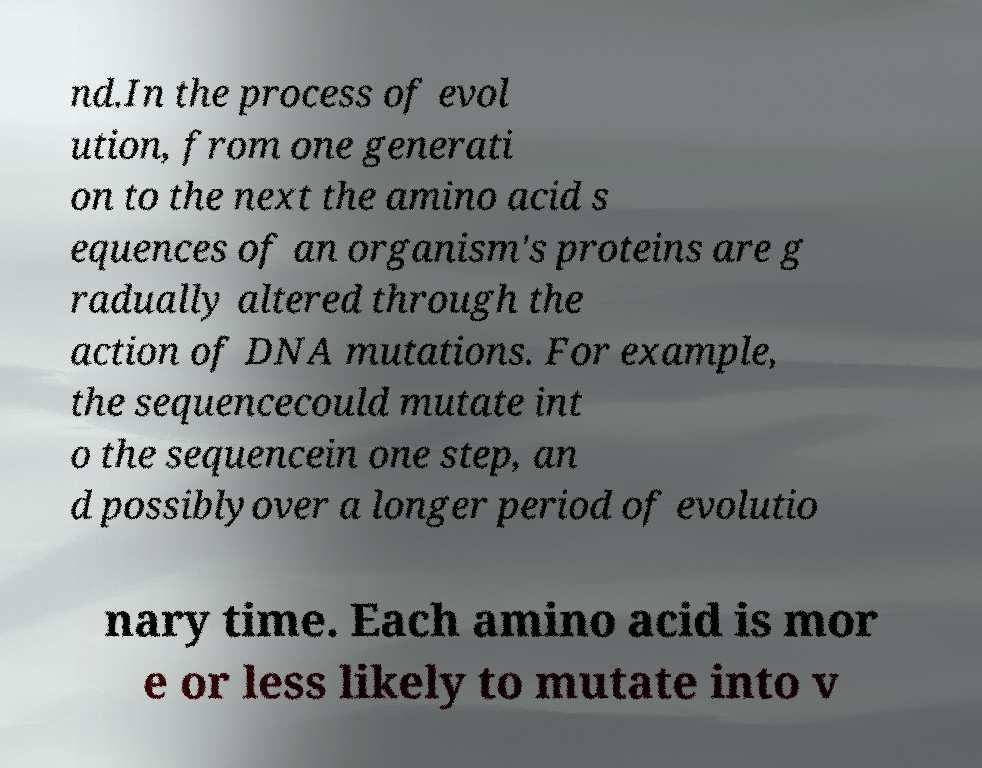For documentation purposes, I need the text within this image transcribed. Could you provide that? nd.In the process of evol ution, from one generati on to the next the amino acid s equences of an organism's proteins are g radually altered through the action of DNA mutations. For example, the sequencecould mutate int o the sequencein one step, an d possiblyover a longer period of evolutio nary time. Each amino acid is mor e or less likely to mutate into v 